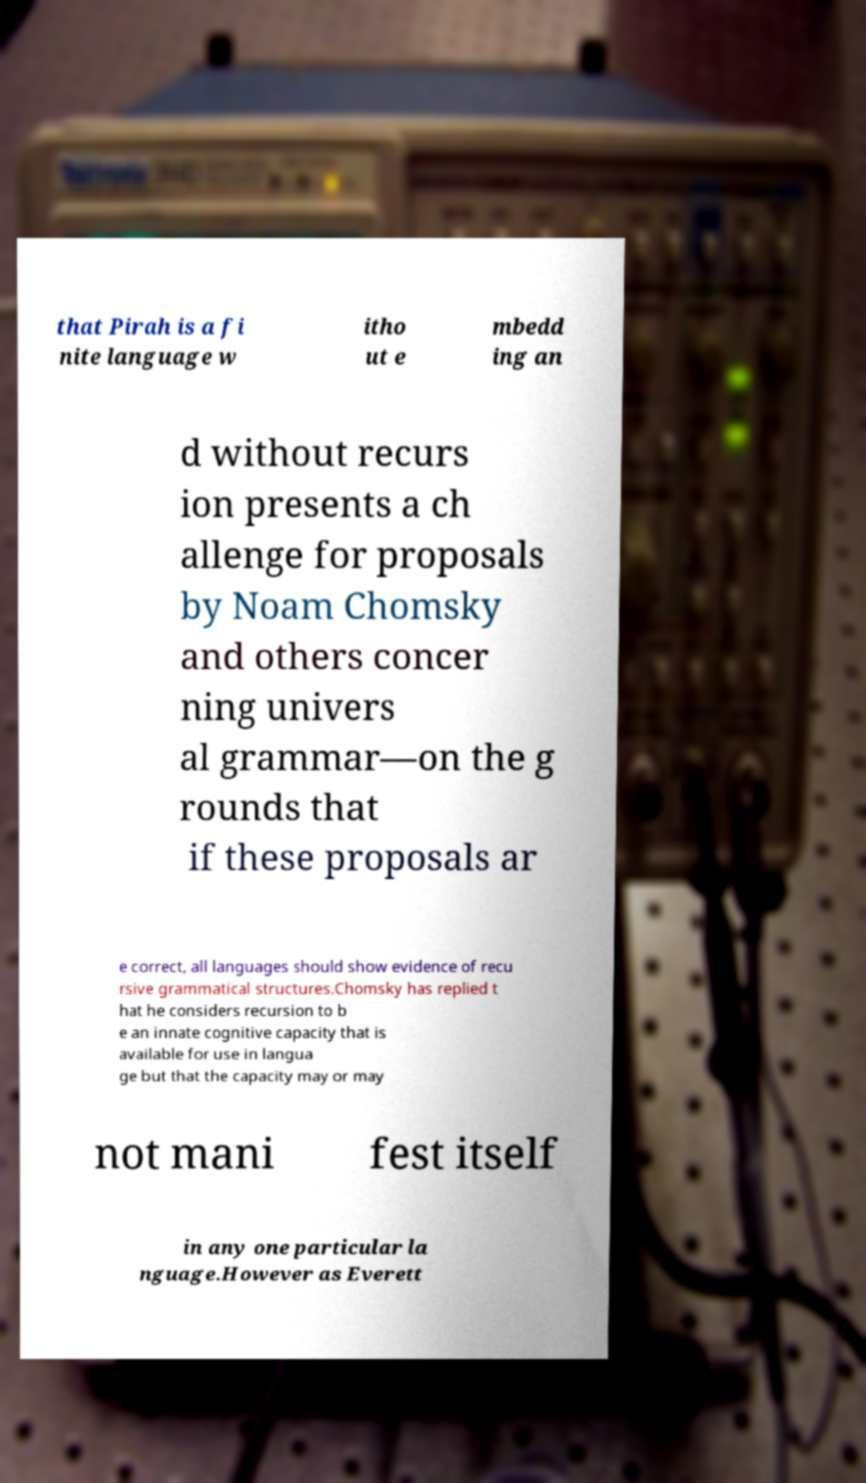Can you read and provide the text displayed in the image?This photo seems to have some interesting text. Can you extract and type it out for me? that Pirah is a fi nite language w itho ut e mbedd ing an d without recurs ion presents a ch allenge for proposals by Noam Chomsky and others concer ning univers al grammar—on the g rounds that if these proposals ar e correct, all languages should show evidence of recu rsive grammatical structures.Chomsky has replied t hat he considers recursion to b e an innate cognitive capacity that is available for use in langua ge but that the capacity may or may not mani fest itself in any one particular la nguage.However as Everett 